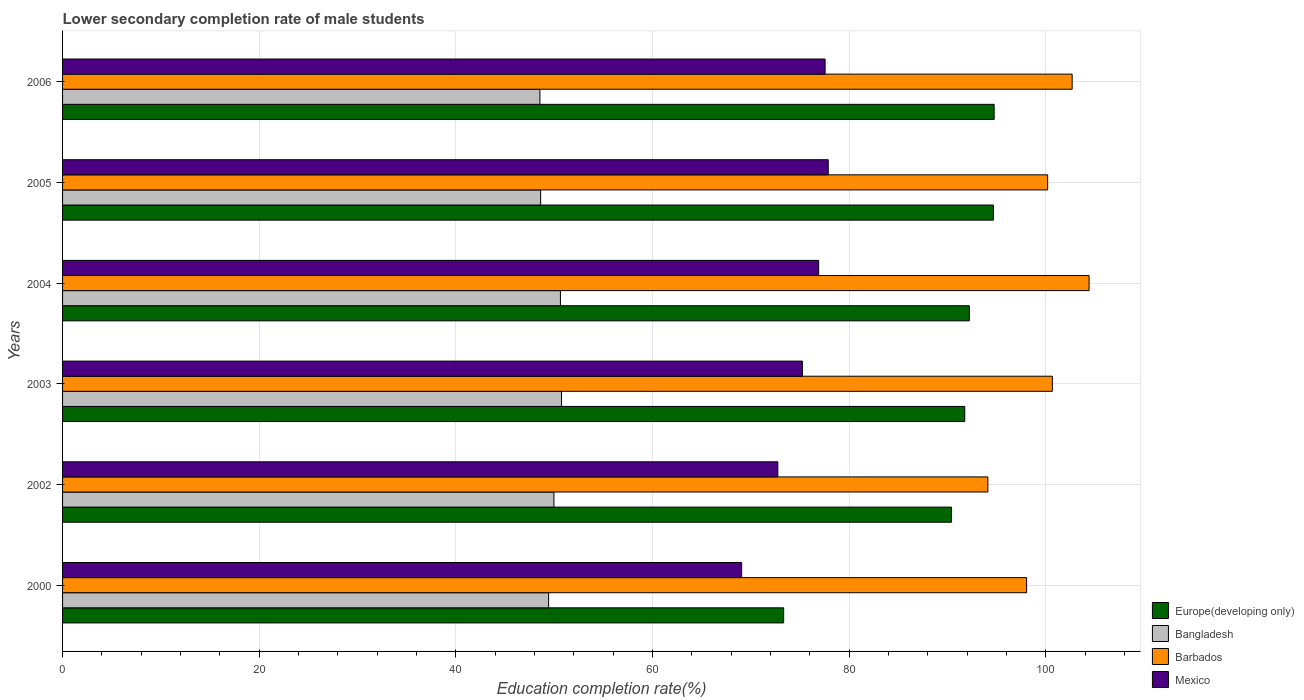How many groups of bars are there?
Keep it short and to the point. 6. Are the number of bars per tick equal to the number of legend labels?
Provide a short and direct response. Yes. Are the number of bars on each tick of the Y-axis equal?
Ensure brevity in your answer.  Yes. How many bars are there on the 2nd tick from the top?
Ensure brevity in your answer.  4. How many bars are there on the 5th tick from the bottom?
Your response must be concise. 4. What is the label of the 2nd group of bars from the top?
Your answer should be compact. 2005. What is the lower secondary completion rate of male students in Mexico in 2000?
Your answer should be compact. 69.07. Across all years, what is the maximum lower secondary completion rate of male students in Mexico?
Offer a very short reply. 77.87. Across all years, what is the minimum lower secondary completion rate of male students in Bangladesh?
Provide a short and direct response. 48.55. In which year was the lower secondary completion rate of male students in Europe(developing only) maximum?
Provide a succinct answer. 2006. What is the total lower secondary completion rate of male students in Bangladesh in the graph?
Keep it short and to the point. 297.96. What is the difference between the lower secondary completion rate of male students in Bangladesh in 2002 and that in 2005?
Keep it short and to the point. 1.35. What is the difference between the lower secondary completion rate of male students in Barbados in 2004 and the lower secondary completion rate of male students in Europe(developing only) in 2002?
Your answer should be very brief. 13.99. What is the average lower secondary completion rate of male students in Europe(developing only) per year?
Give a very brief answer. 89.53. In the year 2005, what is the difference between the lower secondary completion rate of male students in Bangladesh and lower secondary completion rate of male students in Mexico?
Your answer should be very brief. -29.25. What is the ratio of the lower secondary completion rate of male students in Barbados in 2002 to that in 2003?
Offer a terse response. 0.93. What is the difference between the highest and the second highest lower secondary completion rate of male students in Bangladesh?
Keep it short and to the point. 0.11. What is the difference between the highest and the lowest lower secondary completion rate of male students in Mexico?
Your answer should be very brief. 8.81. What does the 4th bar from the top in 2006 represents?
Ensure brevity in your answer.  Europe(developing only). What does the 1st bar from the bottom in 2006 represents?
Give a very brief answer. Europe(developing only). Is it the case that in every year, the sum of the lower secondary completion rate of male students in Europe(developing only) and lower secondary completion rate of male students in Bangladesh is greater than the lower secondary completion rate of male students in Mexico?
Keep it short and to the point. Yes. Are all the bars in the graph horizontal?
Keep it short and to the point. Yes. Does the graph contain any zero values?
Your answer should be compact. No. Does the graph contain grids?
Your answer should be compact. Yes. How are the legend labels stacked?
Provide a short and direct response. Vertical. What is the title of the graph?
Provide a succinct answer. Lower secondary completion rate of male students. Does "Liechtenstein" appear as one of the legend labels in the graph?
Keep it short and to the point. No. What is the label or title of the X-axis?
Offer a terse response. Education completion rate(%). What is the label or title of the Y-axis?
Offer a terse response. Years. What is the Education completion rate(%) in Europe(developing only) in 2000?
Your answer should be compact. 73.34. What is the Education completion rate(%) in Bangladesh in 2000?
Make the answer very short. 49.43. What is the Education completion rate(%) of Barbados in 2000?
Offer a terse response. 98.05. What is the Education completion rate(%) of Mexico in 2000?
Provide a short and direct response. 69.07. What is the Education completion rate(%) in Europe(developing only) in 2002?
Your response must be concise. 90.41. What is the Education completion rate(%) of Bangladesh in 2002?
Your response must be concise. 49.97. What is the Education completion rate(%) in Barbados in 2002?
Make the answer very short. 94.11. What is the Education completion rate(%) in Mexico in 2002?
Your response must be concise. 72.75. What is the Education completion rate(%) in Europe(developing only) in 2003?
Offer a terse response. 91.76. What is the Education completion rate(%) of Bangladesh in 2003?
Give a very brief answer. 50.75. What is the Education completion rate(%) in Barbados in 2003?
Make the answer very short. 100.67. What is the Education completion rate(%) in Mexico in 2003?
Your answer should be compact. 75.26. What is the Education completion rate(%) of Europe(developing only) in 2004?
Your answer should be compact. 92.22. What is the Education completion rate(%) in Bangladesh in 2004?
Your response must be concise. 50.63. What is the Education completion rate(%) of Barbados in 2004?
Your response must be concise. 104.4. What is the Education completion rate(%) of Mexico in 2004?
Make the answer very short. 76.9. What is the Education completion rate(%) of Europe(developing only) in 2005?
Keep it short and to the point. 94.68. What is the Education completion rate(%) of Bangladesh in 2005?
Provide a succinct answer. 48.62. What is the Education completion rate(%) in Barbados in 2005?
Ensure brevity in your answer.  100.19. What is the Education completion rate(%) in Mexico in 2005?
Your answer should be very brief. 77.87. What is the Education completion rate(%) in Europe(developing only) in 2006?
Make the answer very short. 94.75. What is the Education completion rate(%) in Bangladesh in 2006?
Provide a succinct answer. 48.55. What is the Education completion rate(%) of Barbados in 2006?
Your answer should be compact. 102.68. What is the Education completion rate(%) in Mexico in 2006?
Make the answer very short. 77.56. Across all years, what is the maximum Education completion rate(%) in Europe(developing only)?
Your response must be concise. 94.75. Across all years, what is the maximum Education completion rate(%) of Bangladesh?
Offer a very short reply. 50.75. Across all years, what is the maximum Education completion rate(%) in Barbados?
Offer a very short reply. 104.4. Across all years, what is the maximum Education completion rate(%) in Mexico?
Your answer should be compact. 77.87. Across all years, what is the minimum Education completion rate(%) in Europe(developing only)?
Ensure brevity in your answer.  73.34. Across all years, what is the minimum Education completion rate(%) of Bangladesh?
Offer a terse response. 48.55. Across all years, what is the minimum Education completion rate(%) in Barbados?
Give a very brief answer. 94.11. Across all years, what is the minimum Education completion rate(%) of Mexico?
Give a very brief answer. 69.07. What is the total Education completion rate(%) of Europe(developing only) in the graph?
Your answer should be very brief. 537.15. What is the total Education completion rate(%) of Bangladesh in the graph?
Give a very brief answer. 297.96. What is the total Education completion rate(%) in Barbados in the graph?
Ensure brevity in your answer.  600.1. What is the total Education completion rate(%) in Mexico in the graph?
Your response must be concise. 449.4. What is the difference between the Education completion rate(%) of Europe(developing only) in 2000 and that in 2002?
Your answer should be compact. -17.07. What is the difference between the Education completion rate(%) in Bangladesh in 2000 and that in 2002?
Offer a very short reply. -0.54. What is the difference between the Education completion rate(%) of Barbados in 2000 and that in 2002?
Provide a short and direct response. 3.94. What is the difference between the Education completion rate(%) in Mexico in 2000 and that in 2002?
Ensure brevity in your answer.  -3.68. What is the difference between the Education completion rate(%) of Europe(developing only) in 2000 and that in 2003?
Provide a short and direct response. -18.42. What is the difference between the Education completion rate(%) of Bangladesh in 2000 and that in 2003?
Give a very brief answer. -1.31. What is the difference between the Education completion rate(%) in Barbados in 2000 and that in 2003?
Offer a terse response. -2.62. What is the difference between the Education completion rate(%) of Mexico in 2000 and that in 2003?
Offer a terse response. -6.19. What is the difference between the Education completion rate(%) in Europe(developing only) in 2000 and that in 2004?
Your answer should be compact. -18.88. What is the difference between the Education completion rate(%) of Bangladesh in 2000 and that in 2004?
Your response must be concise. -1.2. What is the difference between the Education completion rate(%) of Barbados in 2000 and that in 2004?
Offer a very short reply. -6.35. What is the difference between the Education completion rate(%) in Mexico in 2000 and that in 2004?
Give a very brief answer. -7.83. What is the difference between the Education completion rate(%) of Europe(developing only) in 2000 and that in 2005?
Provide a succinct answer. -21.34. What is the difference between the Education completion rate(%) in Bangladesh in 2000 and that in 2005?
Your answer should be very brief. 0.81. What is the difference between the Education completion rate(%) in Barbados in 2000 and that in 2005?
Ensure brevity in your answer.  -2.14. What is the difference between the Education completion rate(%) of Mexico in 2000 and that in 2005?
Provide a short and direct response. -8.8. What is the difference between the Education completion rate(%) of Europe(developing only) in 2000 and that in 2006?
Your answer should be very brief. -21.41. What is the difference between the Education completion rate(%) in Bangladesh in 2000 and that in 2006?
Make the answer very short. 0.88. What is the difference between the Education completion rate(%) in Barbados in 2000 and that in 2006?
Offer a very short reply. -4.63. What is the difference between the Education completion rate(%) in Mexico in 2000 and that in 2006?
Give a very brief answer. -8.49. What is the difference between the Education completion rate(%) in Europe(developing only) in 2002 and that in 2003?
Offer a very short reply. -1.34. What is the difference between the Education completion rate(%) of Bangladesh in 2002 and that in 2003?
Your answer should be very brief. -0.77. What is the difference between the Education completion rate(%) of Barbados in 2002 and that in 2003?
Offer a very short reply. -6.56. What is the difference between the Education completion rate(%) in Mexico in 2002 and that in 2003?
Make the answer very short. -2.51. What is the difference between the Education completion rate(%) in Europe(developing only) in 2002 and that in 2004?
Your answer should be very brief. -1.81. What is the difference between the Education completion rate(%) of Bangladesh in 2002 and that in 2004?
Offer a very short reply. -0.66. What is the difference between the Education completion rate(%) in Barbados in 2002 and that in 2004?
Your response must be concise. -10.29. What is the difference between the Education completion rate(%) in Mexico in 2002 and that in 2004?
Give a very brief answer. -4.15. What is the difference between the Education completion rate(%) of Europe(developing only) in 2002 and that in 2005?
Your answer should be compact. -4.26. What is the difference between the Education completion rate(%) in Bangladesh in 2002 and that in 2005?
Keep it short and to the point. 1.35. What is the difference between the Education completion rate(%) of Barbados in 2002 and that in 2005?
Keep it short and to the point. -6.08. What is the difference between the Education completion rate(%) in Mexico in 2002 and that in 2005?
Offer a terse response. -5.13. What is the difference between the Education completion rate(%) in Europe(developing only) in 2002 and that in 2006?
Your answer should be very brief. -4.34. What is the difference between the Education completion rate(%) in Bangladesh in 2002 and that in 2006?
Your response must be concise. 1.42. What is the difference between the Education completion rate(%) of Barbados in 2002 and that in 2006?
Your answer should be very brief. -8.57. What is the difference between the Education completion rate(%) of Mexico in 2002 and that in 2006?
Your answer should be very brief. -4.81. What is the difference between the Education completion rate(%) in Europe(developing only) in 2003 and that in 2004?
Ensure brevity in your answer.  -0.46. What is the difference between the Education completion rate(%) in Bangladesh in 2003 and that in 2004?
Give a very brief answer. 0.11. What is the difference between the Education completion rate(%) in Barbados in 2003 and that in 2004?
Your response must be concise. -3.74. What is the difference between the Education completion rate(%) in Mexico in 2003 and that in 2004?
Give a very brief answer. -1.64. What is the difference between the Education completion rate(%) of Europe(developing only) in 2003 and that in 2005?
Make the answer very short. -2.92. What is the difference between the Education completion rate(%) of Bangladesh in 2003 and that in 2005?
Ensure brevity in your answer.  2.12. What is the difference between the Education completion rate(%) of Barbados in 2003 and that in 2005?
Your answer should be very brief. 0.48. What is the difference between the Education completion rate(%) of Mexico in 2003 and that in 2005?
Your answer should be very brief. -2.62. What is the difference between the Education completion rate(%) of Europe(developing only) in 2003 and that in 2006?
Your response must be concise. -2.99. What is the difference between the Education completion rate(%) of Bangladesh in 2003 and that in 2006?
Offer a very short reply. 2.2. What is the difference between the Education completion rate(%) in Barbados in 2003 and that in 2006?
Provide a succinct answer. -2.01. What is the difference between the Education completion rate(%) of Mexico in 2003 and that in 2006?
Make the answer very short. -2.3. What is the difference between the Education completion rate(%) in Europe(developing only) in 2004 and that in 2005?
Make the answer very short. -2.46. What is the difference between the Education completion rate(%) of Bangladesh in 2004 and that in 2005?
Provide a succinct answer. 2.01. What is the difference between the Education completion rate(%) of Barbados in 2004 and that in 2005?
Offer a terse response. 4.21. What is the difference between the Education completion rate(%) of Mexico in 2004 and that in 2005?
Your answer should be compact. -0.97. What is the difference between the Education completion rate(%) of Europe(developing only) in 2004 and that in 2006?
Make the answer very short. -2.53. What is the difference between the Education completion rate(%) in Bangladesh in 2004 and that in 2006?
Offer a terse response. 2.08. What is the difference between the Education completion rate(%) in Barbados in 2004 and that in 2006?
Your answer should be very brief. 1.72. What is the difference between the Education completion rate(%) in Mexico in 2004 and that in 2006?
Make the answer very short. -0.66. What is the difference between the Education completion rate(%) of Europe(developing only) in 2005 and that in 2006?
Your answer should be compact. -0.07. What is the difference between the Education completion rate(%) of Bangladesh in 2005 and that in 2006?
Make the answer very short. 0.07. What is the difference between the Education completion rate(%) of Barbados in 2005 and that in 2006?
Your response must be concise. -2.49. What is the difference between the Education completion rate(%) of Mexico in 2005 and that in 2006?
Offer a very short reply. 0.32. What is the difference between the Education completion rate(%) in Europe(developing only) in 2000 and the Education completion rate(%) in Bangladesh in 2002?
Your response must be concise. 23.37. What is the difference between the Education completion rate(%) of Europe(developing only) in 2000 and the Education completion rate(%) of Barbados in 2002?
Provide a short and direct response. -20.77. What is the difference between the Education completion rate(%) of Europe(developing only) in 2000 and the Education completion rate(%) of Mexico in 2002?
Keep it short and to the point. 0.59. What is the difference between the Education completion rate(%) of Bangladesh in 2000 and the Education completion rate(%) of Barbados in 2002?
Keep it short and to the point. -44.67. What is the difference between the Education completion rate(%) in Bangladesh in 2000 and the Education completion rate(%) in Mexico in 2002?
Ensure brevity in your answer.  -23.31. What is the difference between the Education completion rate(%) of Barbados in 2000 and the Education completion rate(%) of Mexico in 2002?
Your response must be concise. 25.3. What is the difference between the Education completion rate(%) of Europe(developing only) in 2000 and the Education completion rate(%) of Bangladesh in 2003?
Keep it short and to the point. 22.59. What is the difference between the Education completion rate(%) of Europe(developing only) in 2000 and the Education completion rate(%) of Barbados in 2003?
Provide a short and direct response. -27.33. What is the difference between the Education completion rate(%) in Europe(developing only) in 2000 and the Education completion rate(%) in Mexico in 2003?
Offer a terse response. -1.92. What is the difference between the Education completion rate(%) of Bangladesh in 2000 and the Education completion rate(%) of Barbados in 2003?
Your answer should be compact. -51.23. What is the difference between the Education completion rate(%) of Bangladesh in 2000 and the Education completion rate(%) of Mexico in 2003?
Offer a very short reply. -25.82. What is the difference between the Education completion rate(%) in Barbados in 2000 and the Education completion rate(%) in Mexico in 2003?
Keep it short and to the point. 22.79. What is the difference between the Education completion rate(%) of Europe(developing only) in 2000 and the Education completion rate(%) of Bangladesh in 2004?
Give a very brief answer. 22.7. What is the difference between the Education completion rate(%) of Europe(developing only) in 2000 and the Education completion rate(%) of Barbados in 2004?
Your response must be concise. -31.06. What is the difference between the Education completion rate(%) in Europe(developing only) in 2000 and the Education completion rate(%) in Mexico in 2004?
Make the answer very short. -3.56. What is the difference between the Education completion rate(%) in Bangladesh in 2000 and the Education completion rate(%) in Barbados in 2004?
Your answer should be very brief. -54.97. What is the difference between the Education completion rate(%) in Bangladesh in 2000 and the Education completion rate(%) in Mexico in 2004?
Ensure brevity in your answer.  -27.47. What is the difference between the Education completion rate(%) in Barbados in 2000 and the Education completion rate(%) in Mexico in 2004?
Ensure brevity in your answer.  21.15. What is the difference between the Education completion rate(%) of Europe(developing only) in 2000 and the Education completion rate(%) of Bangladesh in 2005?
Your answer should be compact. 24.72. What is the difference between the Education completion rate(%) of Europe(developing only) in 2000 and the Education completion rate(%) of Barbados in 2005?
Offer a very short reply. -26.85. What is the difference between the Education completion rate(%) of Europe(developing only) in 2000 and the Education completion rate(%) of Mexico in 2005?
Your response must be concise. -4.53. What is the difference between the Education completion rate(%) of Bangladesh in 2000 and the Education completion rate(%) of Barbados in 2005?
Give a very brief answer. -50.75. What is the difference between the Education completion rate(%) of Bangladesh in 2000 and the Education completion rate(%) of Mexico in 2005?
Offer a very short reply. -28.44. What is the difference between the Education completion rate(%) in Barbados in 2000 and the Education completion rate(%) in Mexico in 2005?
Provide a succinct answer. 20.18. What is the difference between the Education completion rate(%) in Europe(developing only) in 2000 and the Education completion rate(%) in Bangladesh in 2006?
Your answer should be compact. 24.79. What is the difference between the Education completion rate(%) of Europe(developing only) in 2000 and the Education completion rate(%) of Barbados in 2006?
Ensure brevity in your answer.  -29.34. What is the difference between the Education completion rate(%) of Europe(developing only) in 2000 and the Education completion rate(%) of Mexico in 2006?
Ensure brevity in your answer.  -4.22. What is the difference between the Education completion rate(%) of Bangladesh in 2000 and the Education completion rate(%) of Barbados in 2006?
Make the answer very short. -53.25. What is the difference between the Education completion rate(%) of Bangladesh in 2000 and the Education completion rate(%) of Mexico in 2006?
Your answer should be compact. -28.12. What is the difference between the Education completion rate(%) of Barbados in 2000 and the Education completion rate(%) of Mexico in 2006?
Your response must be concise. 20.49. What is the difference between the Education completion rate(%) of Europe(developing only) in 2002 and the Education completion rate(%) of Bangladesh in 2003?
Ensure brevity in your answer.  39.67. What is the difference between the Education completion rate(%) in Europe(developing only) in 2002 and the Education completion rate(%) in Barbados in 2003?
Give a very brief answer. -10.26. What is the difference between the Education completion rate(%) of Europe(developing only) in 2002 and the Education completion rate(%) of Mexico in 2003?
Provide a short and direct response. 15.16. What is the difference between the Education completion rate(%) of Bangladesh in 2002 and the Education completion rate(%) of Barbados in 2003?
Keep it short and to the point. -50.69. What is the difference between the Education completion rate(%) in Bangladesh in 2002 and the Education completion rate(%) in Mexico in 2003?
Provide a succinct answer. -25.28. What is the difference between the Education completion rate(%) in Barbados in 2002 and the Education completion rate(%) in Mexico in 2003?
Give a very brief answer. 18.85. What is the difference between the Education completion rate(%) of Europe(developing only) in 2002 and the Education completion rate(%) of Bangladesh in 2004?
Keep it short and to the point. 39.78. What is the difference between the Education completion rate(%) of Europe(developing only) in 2002 and the Education completion rate(%) of Barbados in 2004?
Provide a succinct answer. -13.99. What is the difference between the Education completion rate(%) in Europe(developing only) in 2002 and the Education completion rate(%) in Mexico in 2004?
Offer a very short reply. 13.51. What is the difference between the Education completion rate(%) in Bangladesh in 2002 and the Education completion rate(%) in Barbados in 2004?
Offer a terse response. -54.43. What is the difference between the Education completion rate(%) of Bangladesh in 2002 and the Education completion rate(%) of Mexico in 2004?
Your response must be concise. -26.93. What is the difference between the Education completion rate(%) in Barbados in 2002 and the Education completion rate(%) in Mexico in 2004?
Make the answer very short. 17.21. What is the difference between the Education completion rate(%) of Europe(developing only) in 2002 and the Education completion rate(%) of Bangladesh in 2005?
Make the answer very short. 41.79. What is the difference between the Education completion rate(%) of Europe(developing only) in 2002 and the Education completion rate(%) of Barbados in 2005?
Make the answer very short. -9.78. What is the difference between the Education completion rate(%) of Europe(developing only) in 2002 and the Education completion rate(%) of Mexico in 2005?
Ensure brevity in your answer.  12.54. What is the difference between the Education completion rate(%) in Bangladesh in 2002 and the Education completion rate(%) in Barbados in 2005?
Provide a succinct answer. -50.22. What is the difference between the Education completion rate(%) in Bangladesh in 2002 and the Education completion rate(%) in Mexico in 2005?
Your answer should be compact. -27.9. What is the difference between the Education completion rate(%) of Barbados in 2002 and the Education completion rate(%) of Mexico in 2005?
Ensure brevity in your answer.  16.24. What is the difference between the Education completion rate(%) in Europe(developing only) in 2002 and the Education completion rate(%) in Bangladesh in 2006?
Provide a succinct answer. 41.86. What is the difference between the Education completion rate(%) of Europe(developing only) in 2002 and the Education completion rate(%) of Barbados in 2006?
Give a very brief answer. -12.27. What is the difference between the Education completion rate(%) in Europe(developing only) in 2002 and the Education completion rate(%) in Mexico in 2006?
Give a very brief answer. 12.86. What is the difference between the Education completion rate(%) in Bangladesh in 2002 and the Education completion rate(%) in Barbados in 2006?
Ensure brevity in your answer.  -52.71. What is the difference between the Education completion rate(%) in Bangladesh in 2002 and the Education completion rate(%) in Mexico in 2006?
Keep it short and to the point. -27.58. What is the difference between the Education completion rate(%) in Barbados in 2002 and the Education completion rate(%) in Mexico in 2006?
Give a very brief answer. 16.55. What is the difference between the Education completion rate(%) of Europe(developing only) in 2003 and the Education completion rate(%) of Bangladesh in 2004?
Your answer should be compact. 41.12. What is the difference between the Education completion rate(%) of Europe(developing only) in 2003 and the Education completion rate(%) of Barbados in 2004?
Your answer should be very brief. -12.65. What is the difference between the Education completion rate(%) of Europe(developing only) in 2003 and the Education completion rate(%) of Mexico in 2004?
Make the answer very short. 14.86. What is the difference between the Education completion rate(%) in Bangladesh in 2003 and the Education completion rate(%) in Barbados in 2004?
Give a very brief answer. -53.66. What is the difference between the Education completion rate(%) in Bangladesh in 2003 and the Education completion rate(%) in Mexico in 2004?
Give a very brief answer. -26.15. What is the difference between the Education completion rate(%) in Barbados in 2003 and the Education completion rate(%) in Mexico in 2004?
Give a very brief answer. 23.77. What is the difference between the Education completion rate(%) of Europe(developing only) in 2003 and the Education completion rate(%) of Bangladesh in 2005?
Offer a very short reply. 43.13. What is the difference between the Education completion rate(%) of Europe(developing only) in 2003 and the Education completion rate(%) of Barbados in 2005?
Provide a succinct answer. -8.43. What is the difference between the Education completion rate(%) of Europe(developing only) in 2003 and the Education completion rate(%) of Mexico in 2005?
Ensure brevity in your answer.  13.88. What is the difference between the Education completion rate(%) of Bangladesh in 2003 and the Education completion rate(%) of Barbados in 2005?
Ensure brevity in your answer.  -49.44. What is the difference between the Education completion rate(%) in Bangladesh in 2003 and the Education completion rate(%) in Mexico in 2005?
Offer a terse response. -27.13. What is the difference between the Education completion rate(%) of Barbados in 2003 and the Education completion rate(%) of Mexico in 2005?
Ensure brevity in your answer.  22.79. What is the difference between the Education completion rate(%) in Europe(developing only) in 2003 and the Education completion rate(%) in Bangladesh in 2006?
Keep it short and to the point. 43.21. What is the difference between the Education completion rate(%) of Europe(developing only) in 2003 and the Education completion rate(%) of Barbados in 2006?
Your answer should be compact. -10.92. What is the difference between the Education completion rate(%) in Europe(developing only) in 2003 and the Education completion rate(%) in Mexico in 2006?
Provide a short and direct response. 14.2. What is the difference between the Education completion rate(%) of Bangladesh in 2003 and the Education completion rate(%) of Barbados in 2006?
Offer a very short reply. -51.93. What is the difference between the Education completion rate(%) of Bangladesh in 2003 and the Education completion rate(%) of Mexico in 2006?
Ensure brevity in your answer.  -26.81. What is the difference between the Education completion rate(%) of Barbados in 2003 and the Education completion rate(%) of Mexico in 2006?
Ensure brevity in your answer.  23.11. What is the difference between the Education completion rate(%) in Europe(developing only) in 2004 and the Education completion rate(%) in Bangladesh in 2005?
Provide a short and direct response. 43.6. What is the difference between the Education completion rate(%) in Europe(developing only) in 2004 and the Education completion rate(%) in Barbados in 2005?
Keep it short and to the point. -7.97. What is the difference between the Education completion rate(%) of Europe(developing only) in 2004 and the Education completion rate(%) of Mexico in 2005?
Ensure brevity in your answer.  14.35. What is the difference between the Education completion rate(%) of Bangladesh in 2004 and the Education completion rate(%) of Barbados in 2005?
Provide a succinct answer. -49.55. What is the difference between the Education completion rate(%) of Bangladesh in 2004 and the Education completion rate(%) of Mexico in 2005?
Your answer should be very brief. -27.24. What is the difference between the Education completion rate(%) in Barbados in 2004 and the Education completion rate(%) in Mexico in 2005?
Your answer should be compact. 26.53. What is the difference between the Education completion rate(%) of Europe(developing only) in 2004 and the Education completion rate(%) of Bangladesh in 2006?
Your response must be concise. 43.67. What is the difference between the Education completion rate(%) in Europe(developing only) in 2004 and the Education completion rate(%) in Barbados in 2006?
Your answer should be very brief. -10.46. What is the difference between the Education completion rate(%) of Europe(developing only) in 2004 and the Education completion rate(%) of Mexico in 2006?
Your answer should be compact. 14.66. What is the difference between the Education completion rate(%) of Bangladesh in 2004 and the Education completion rate(%) of Barbados in 2006?
Your answer should be compact. -52.05. What is the difference between the Education completion rate(%) of Bangladesh in 2004 and the Education completion rate(%) of Mexico in 2006?
Your answer should be very brief. -26.92. What is the difference between the Education completion rate(%) in Barbados in 2004 and the Education completion rate(%) in Mexico in 2006?
Offer a terse response. 26.85. What is the difference between the Education completion rate(%) of Europe(developing only) in 2005 and the Education completion rate(%) of Bangladesh in 2006?
Provide a short and direct response. 46.12. What is the difference between the Education completion rate(%) of Europe(developing only) in 2005 and the Education completion rate(%) of Barbados in 2006?
Ensure brevity in your answer.  -8.01. What is the difference between the Education completion rate(%) of Europe(developing only) in 2005 and the Education completion rate(%) of Mexico in 2006?
Your answer should be compact. 17.12. What is the difference between the Education completion rate(%) in Bangladesh in 2005 and the Education completion rate(%) in Barbados in 2006?
Ensure brevity in your answer.  -54.06. What is the difference between the Education completion rate(%) of Bangladesh in 2005 and the Education completion rate(%) of Mexico in 2006?
Ensure brevity in your answer.  -28.93. What is the difference between the Education completion rate(%) in Barbados in 2005 and the Education completion rate(%) in Mexico in 2006?
Your answer should be very brief. 22.63. What is the average Education completion rate(%) in Europe(developing only) per year?
Offer a very short reply. 89.53. What is the average Education completion rate(%) in Bangladesh per year?
Your answer should be compact. 49.66. What is the average Education completion rate(%) of Barbados per year?
Provide a succinct answer. 100.02. What is the average Education completion rate(%) of Mexico per year?
Offer a terse response. 74.9. In the year 2000, what is the difference between the Education completion rate(%) of Europe(developing only) and Education completion rate(%) of Bangladesh?
Your answer should be compact. 23.9. In the year 2000, what is the difference between the Education completion rate(%) in Europe(developing only) and Education completion rate(%) in Barbados?
Offer a very short reply. -24.71. In the year 2000, what is the difference between the Education completion rate(%) of Europe(developing only) and Education completion rate(%) of Mexico?
Make the answer very short. 4.27. In the year 2000, what is the difference between the Education completion rate(%) of Bangladesh and Education completion rate(%) of Barbados?
Offer a very short reply. -48.61. In the year 2000, what is the difference between the Education completion rate(%) of Bangladesh and Education completion rate(%) of Mexico?
Provide a short and direct response. -19.63. In the year 2000, what is the difference between the Education completion rate(%) in Barbados and Education completion rate(%) in Mexico?
Your answer should be very brief. 28.98. In the year 2002, what is the difference between the Education completion rate(%) in Europe(developing only) and Education completion rate(%) in Bangladesh?
Keep it short and to the point. 40.44. In the year 2002, what is the difference between the Education completion rate(%) in Europe(developing only) and Education completion rate(%) in Barbados?
Provide a short and direct response. -3.7. In the year 2002, what is the difference between the Education completion rate(%) of Europe(developing only) and Education completion rate(%) of Mexico?
Keep it short and to the point. 17.67. In the year 2002, what is the difference between the Education completion rate(%) in Bangladesh and Education completion rate(%) in Barbados?
Your answer should be very brief. -44.14. In the year 2002, what is the difference between the Education completion rate(%) in Bangladesh and Education completion rate(%) in Mexico?
Keep it short and to the point. -22.77. In the year 2002, what is the difference between the Education completion rate(%) in Barbados and Education completion rate(%) in Mexico?
Provide a short and direct response. 21.36. In the year 2003, what is the difference between the Education completion rate(%) in Europe(developing only) and Education completion rate(%) in Bangladesh?
Provide a short and direct response. 41.01. In the year 2003, what is the difference between the Education completion rate(%) of Europe(developing only) and Education completion rate(%) of Barbados?
Keep it short and to the point. -8.91. In the year 2003, what is the difference between the Education completion rate(%) in Europe(developing only) and Education completion rate(%) in Mexico?
Keep it short and to the point. 16.5. In the year 2003, what is the difference between the Education completion rate(%) of Bangladesh and Education completion rate(%) of Barbados?
Provide a succinct answer. -49.92. In the year 2003, what is the difference between the Education completion rate(%) in Bangladesh and Education completion rate(%) in Mexico?
Keep it short and to the point. -24.51. In the year 2003, what is the difference between the Education completion rate(%) of Barbados and Education completion rate(%) of Mexico?
Provide a short and direct response. 25.41. In the year 2004, what is the difference between the Education completion rate(%) of Europe(developing only) and Education completion rate(%) of Bangladesh?
Provide a short and direct response. 41.59. In the year 2004, what is the difference between the Education completion rate(%) in Europe(developing only) and Education completion rate(%) in Barbados?
Ensure brevity in your answer.  -12.18. In the year 2004, what is the difference between the Education completion rate(%) of Europe(developing only) and Education completion rate(%) of Mexico?
Your answer should be compact. 15.32. In the year 2004, what is the difference between the Education completion rate(%) of Bangladesh and Education completion rate(%) of Barbados?
Offer a terse response. -53.77. In the year 2004, what is the difference between the Education completion rate(%) of Bangladesh and Education completion rate(%) of Mexico?
Make the answer very short. -26.27. In the year 2004, what is the difference between the Education completion rate(%) of Barbados and Education completion rate(%) of Mexico?
Your answer should be very brief. 27.5. In the year 2005, what is the difference between the Education completion rate(%) of Europe(developing only) and Education completion rate(%) of Bangladesh?
Provide a short and direct response. 46.05. In the year 2005, what is the difference between the Education completion rate(%) of Europe(developing only) and Education completion rate(%) of Barbados?
Your answer should be very brief. -5.51. In the year 2005, what is the difference between the Education completion rate(%) in Europe(developing only) and Education completion rate(%) in Mexico?
Provide a short and direct response. 16.8. In the year 2005, what is the difference between the Education completion rate(%) of Bangladesh and Education completion rate(%) of Barbados?
Keep it short and to the point. -51.57. In the year 2005, what is the difference between the Education completion rate(%) in Bangladesh and Education completion rate(%) in Mexico?
Your response must be concise. -29.25. In the year 2005, what is the difference between the Education completion rate(%) in Barbados and Education completion rate(%) in Mexico?
Your answer should be very brief. 22.32. In the year 2006, what is the difference between the Education completion rate(%) of Europe(developing only) and Education completion rate(%) of Bangladesh?
Offer a terse response. 46.2. In the year 2006, what is the difference between the Education completion rate(%) in Europe(developing only) and Education completion rate(%) in Barbados?
Give a very brief answer. -7.93. In the year 2006, what is the difference between the Education completion rate(%) in Europe(developing only) and Education completion rate(%) in Mexico?
Offer a terse response. 17.19. In the year 2006, what is the difference between the Education completion rate(%) of Bangladesh and Education completion rate(%) of Barbados?
Make the answer very short. -54.13. In the year 2006, what is the difference between the Education completion rate(%) in Bangladesh and Education completion rate(%) in Mexico?
Provide a short and direct response. -29. In the year 2006, what is the difference between the Education completion rate(%) of Barbados and Education completion rate(%) of Mexico?
Ensure brevity in your answer.  25.13. What is the ratio of the Education completion rate(%) in Europe(developing only) in 2000 to that in 2002?
Your answer should be compact. 0.81. What is the ratio of the Education completion rate(%) in Bangladesh in 2000 to that in 2002?
Ensure brevity in your answer.  0.99. What is the ratio of the Education completion rate(%) of Barbados in 2000 to that in 2002?
Provide a succinct answer. 1.04. What is the ratio of the Education completion rate(%) in Mexico in 2000 to that in 2002?
Give a very brief answer. 0.95. What is the ratio of the Education completion rate(%) in Europe(developing only) in 2000 to that in 2003?
Offer a very short reply. 0.8. What is the ratio of the Education completion rate(%) in Bangladesh in 2000 to that in 2003?
Provide a short and direct response. 0.97. What is the ratio of the Education completion rate(%) in Mexico in 2000 to that in 2003?
Your answer should be very brief. 0.92. What is the ratio of the Education completion rate(%) of Europe(developing only) in 2000 to that in 2004?
Ensure brevity in your answer.  0.8. What is the ratio of the Education completion rate(%) of Bangladesh in 2000 to that in 2004?
Your response must be concise. 0.98. What is the ratio of the Education completion rate(%) in Barbados in 2000 to that in 2004?
Offer a very short reply. 0.94. What is the ratio of the Education completion rate(%) of Mexico in 2000 to that in 2004?
Give a very brief answer. 0.9. What is the ratio of the Education completion rate(%) in Europe(developing only) in 2000 to that in 2005?
Offer a very short reply. 0.77. What is the ratio of the Education completion rate(%) of Bangladesh in 2000 to that in 2005?
Keep it short and to the point. 1.02. What is the ratio of the Education completion rate(%) in Barbados in 2000 to that in 2005?
Give a very brief answer. 0.98. What is the ratio of the Education completion rate(%) in Mexico in 2000 to that in 2005?
Provide a succinct answer. 0.89. What is the ratio of the Education completion rate(%) of Europe(developing only) in 2000 to that in 2006?
Offer a very short reply. 0.77. What is the ratio of the Education completion rate(%) of Bangladesh in 2000 to that in 2006?
Ensure brevity in your answer.  1.02. What is the ratio of the Education completion rate(%) in Barbados in 2000 to that in 2006?
Offer a very short reply. 0.95. What is the ratio of the Education completion rate(%) in Mexico in 2000 to that in 2006?
Offer a terse response. 0.89. What is the ratio of the Education completion rate(%) of Bangladesh in 2002 to that in 2003?
Your answer should be very brief. 0.98. What is the ratio of the Education completion rate(%) of Barbados in 2002 to that in 2003?
Your answer should be compact. 0.93. What is the ratio of the Education completion rate(%) in Mexico in 2002 to that in 2003?
Your response must be concise. 0.97. What is the ratio of the Education completion rate(%) in Europe(developing only) in 2002 to that in 2004?
Give a very brief answer. 0.98. What is the ratio of the Education completion rate(%) in Bangladesh in 2002 to that in 2004?
Offer a very short reply. 0.99. What is the ratio of the Education completion rate(%) in Barbados in 2002 to that in 2004?
Ensure brevity in your answer.  0.9. What is the ratio of the Education completion rate(%) in Mexico in 2002 to that in 2004?
Provide a succinct answer. 0.95. What is the ratio of the Education completion rate(%) in Europe(developing only) in 2002 to that in 2005?
Provide a succinct answer. 0.95. What is the ratio of the Education completion rate(%) in Bangladesh in 2002 to that in 2005?
Your answer should be very brief. 1.03. What is the ratio of the Education completion rate(%) in Barbados in 2002 to that in 2005?
Make the answer very short. 0.94. What is the ratio of the Education completion rate(%) in Mexico in 2002 to that in 2005?
Give a very brief answer. 0.93. What is the ratio of the Education completion rate(%) of Europe(developing only) in 2002 to that in 2006?
Ensure brevity in your answer.  0.95. What is the ratio of the Education completion rate(%) of Bangladesh in 2002 to that in 2006?
Provide a short and direct response. 1.03. What is the ratio of the Education completion rate(%) of Barbados in 2002 to that in 2006?
Give a very brief answer. 0.92. What is the ratio of the Education completion rate(%) of Mexico in 2002 to that in 2006?
Offer a terse response. 0.94. What is the ratio of the Education completion rate(%) of Europe(developing only) in 2003 to that in 2004?
Your answer should be compact. 0.99. What is the ratio of the Education completion rate(%) in Barbados in 2003 to that in 2004?
Provide a short and direct response. 0.96. What is the ratio of the Education completion rate(%) in Mexico in 2003 to that in 2004?
Your answer should be compact. 0.98. What is the ratio of the Education completion rate(%) of Europe(developing only) in 2003 to that in 2005?
Offer a very short reply. 0.97. What is the ratio of the Education completion rate(%) in Bangladesh in 2003 to that in 2005?
Offer a very short reply. 1.04. What is the ratio of the Education completion rate(%) in Barbados in 2003 to that in 2005?
Give a very brief answer. 1. What is the ratio of the Education completion rate(%) in Mexico in 2003 to that in 2005?
Your answer should be compact. 0.97. What is the ratio of the Education completion rate(%) in Europe(developing only) in 2003 to that in 2006?
Your response must be concise. 0.97. What is the ratio of the Education completion rate(%) of Bangladesh in 2003 to that in 2006?
Offer a very short reply. 1.05. What is the ratio of the Education completion rate(%) of Barbados in 2003 to that in 2006?
Your answer should be compact. 0.98. What is the ratio of the Education completion rate(%) of Mexico in 2003 to that in 2006?
Keep it short and to the point. 0.97. What is the ratio of the Education completion rate(%) in Europe(developing only) in 2004 to that in 2005?
Ensure brevity in your answer.  0.97. What is the ratio of the Education completion rate(%) in Bangladesh in 2004 to that in 2005?
Provide a short and direct response. 1.04. What is the ratio of the Education completion rate(%) of Barbados in 2004 to that in 2005?
Ensure brevity in your answer.  1.04. What is the ratio of the Education completion rate(%) in Mexico in 2004 to that in 2005?
Offer a terse response. 0.99. What is the ratio of the Education completion rate(%) in Europe(developing only) in 2004 to that in 2006?
Make the answer very short. 0.97. What is the ratio of the Education completion rate(%) in Bangladesh in 2004 to that in 2006?
Make the answer very short. 1.04. What is the ratio of the Education completion rate(%) of Barbados in 2004 to that in 2006?
Offer a very short reply. 1.02. What is the ratio of the Education completion rate(%) in Mexico in 2004 to that in 2006?
Provide a short and direct response. 0.99. What is the ratio of the Education completion rate(%) in Europe(developing only) in 2005 to that in 2006?
Make the answer very short. 1. What is the ratio of the Education completion rate(%) in Bangladesh in 2005 to that in 2006?
Give a very brief answer. 1. What is the ratio of the Education completion rate(%) of Barbados in 2005 to that in 2006?
Ensure brevity in your answer.  0.98. What is the difference between the highest and the second highest Education completion rate(%) of Europe(developing only)?
Your answer should be compact. 0.07. What is the difference between the highest and the second highest Education completion rate(%) of Bangladesh?
Ensure brevity in your answer.  0.11. What is the difference between the highest and the second highest Education completion rate(%) in Barbados?
Your response must be concise. 1.72. What is the difference between the highest and the second highest Education completion rate(%) in Mexico?
Give a very brief answer. 0.32. What is the difference between the highest and the lowest Education completion rate(%) in Europe(developing only)?
Make the answer very short. 21.41. What is the difference between the highest and the lowest Education completion rate(%) of Bangladesh?
Provide a short and direct response. 2.2. What is the difference between the highest and the lowest Education completion rate(%) of Barbados?
Your response must be concise. 10.29. What is the difference between the highest and the lowest Education completion rate(%) in Mexico?
Your response must be concise. 8.8. 